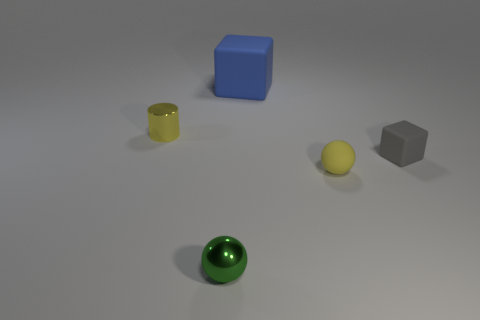Is there anything else that has the same size as the blue rubber cube?
Give a very brief answer. No. What is the size of the cylinder that is the same color as the rubber sphere?
Your response must be concise. Small. Is there anything else that has the same material as the tiny yellow cylinder?
Give a very brief answer. Yes. There is a cube that is in front of the metal thing behind the green thing; what size is it?
Provide a short and direct response. Small. Are there the same number of gray things that are in front of the small yellow ball and yellow cylinders?
Your response must be concise. No. What number of other things are the same color as the tiny rubber sphere?
Provide a succinct answer. 1. Are there fewer big blue matte cubes that are behind the blue matte cube than brown cylinders?
Your response must be concise. No. Is there a red shiny block of the same size as the cylinder?
Offer a very short reply. No. Do the tiny shiny cylinder and the tiny matte thing on the left side of the gray thing have the same color?
Offer a very short reply. Yes. How many large blue cubes are behind the cube to the right of the big block?
Your answer should be compact. 1. 